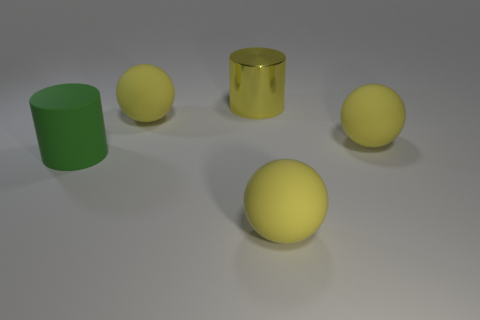Subtract all green cylinders. How many cylinders are left? 1 Add 5 green rubber cylinders. How many objects exist? 10 Subtract 1 balls. How many balls are left? 2 Subtract all cylinders. How many objects are left? 3 Subtract all large red metal cylinders. Subtract all large yellow shiny objects. How many objects are left? 4 Add 2 big yellow balls. How many big yellow balls are left? 5 Add 4 tiny rubber spheres. How many tiny rubber spheres exist? 4 Subtract 0 yellow cubes. How many objects are left? 5 Subtract all red spheres. Subtract all green cubes. How many spheres are left? 3 